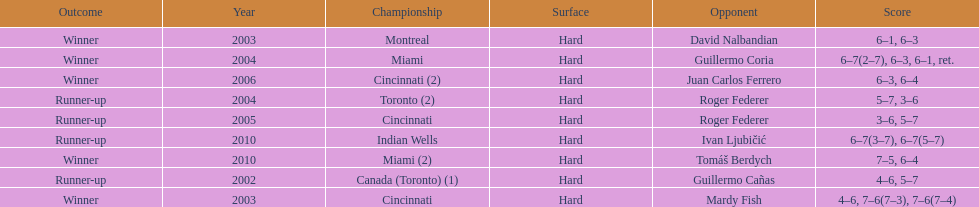How many times were roddick's opponents not from the usa? 8. 